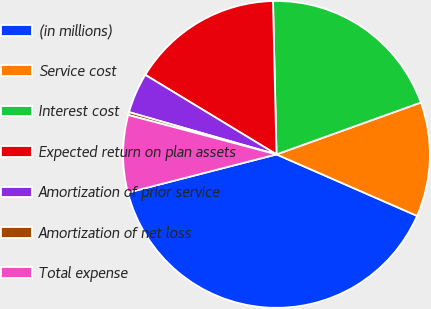Convert chart to OTSL. <chart><loc_0><loc_0><loc_500><loc_500><pie_chart><fcel>(in millions)<fcel>Service cost<fcel>Interest cost<fcel>Expected return on plan assets<fcel>Amortization of prior service<fcel>Amortization of net loss<fcel>Total expense<nl><fcel>39.43%<fcel>12.05%<fcel>19.87%<fcel>15.96%<fcel>4.23%<fcel>0.31%<fcel>8.14%<nl></chart> 